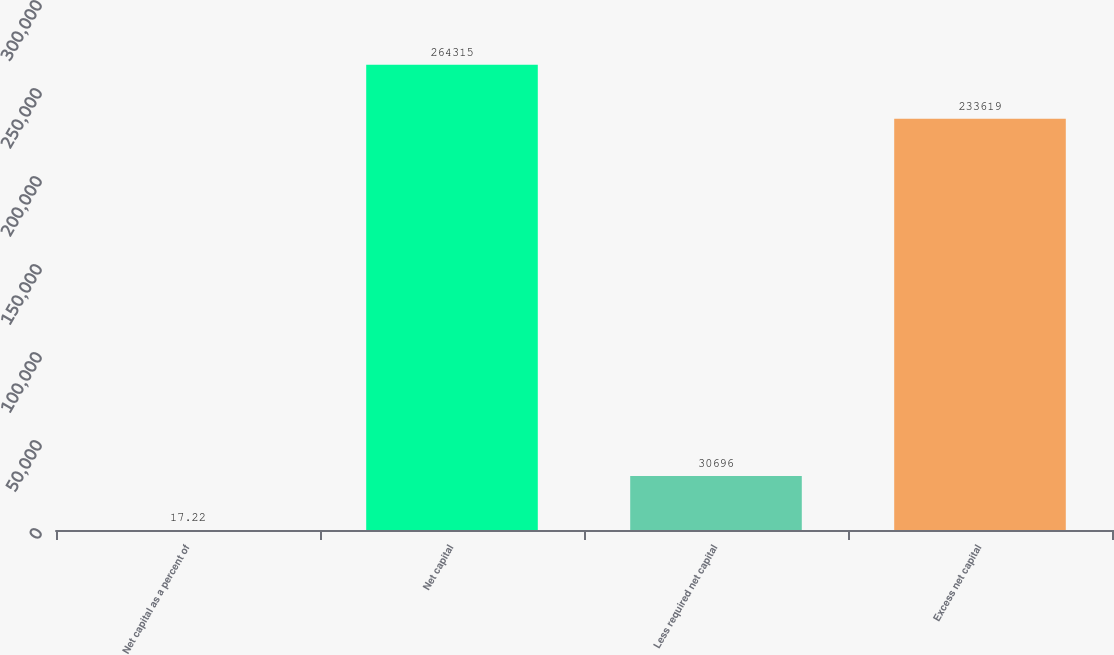Convert chart to OTSL. <chart><loc_0><loc_0><loc_500><loc_500><bar_chart><fcel>Net capital as a percent of<fcel>Net capital<fcel>Less required net capital<fcel>Excess net capital<nl><fcel>17.22<fcel>264315<fcel>30696<fcel>233619<nl></chart> 